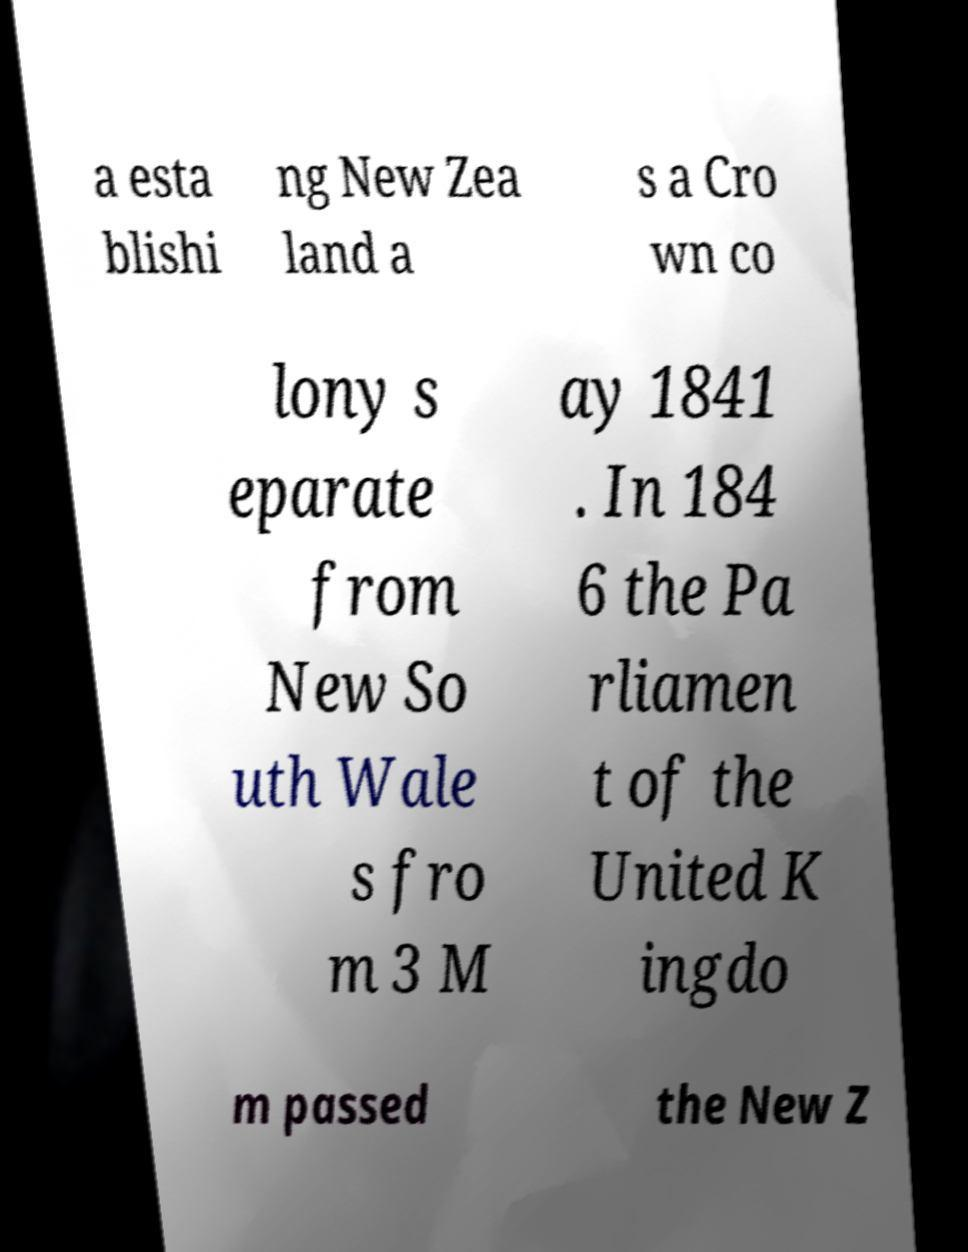For documentation purposes, I need the text within this image transcribed. Could you provide that? a esta blishi ng New Zea land a s a Cro wn co lony s eparate from New So uth Wale s fro m 3 M ay 1841 . In 184 6 the Pa rliamen t of the United K ingdo m passed the New Z 